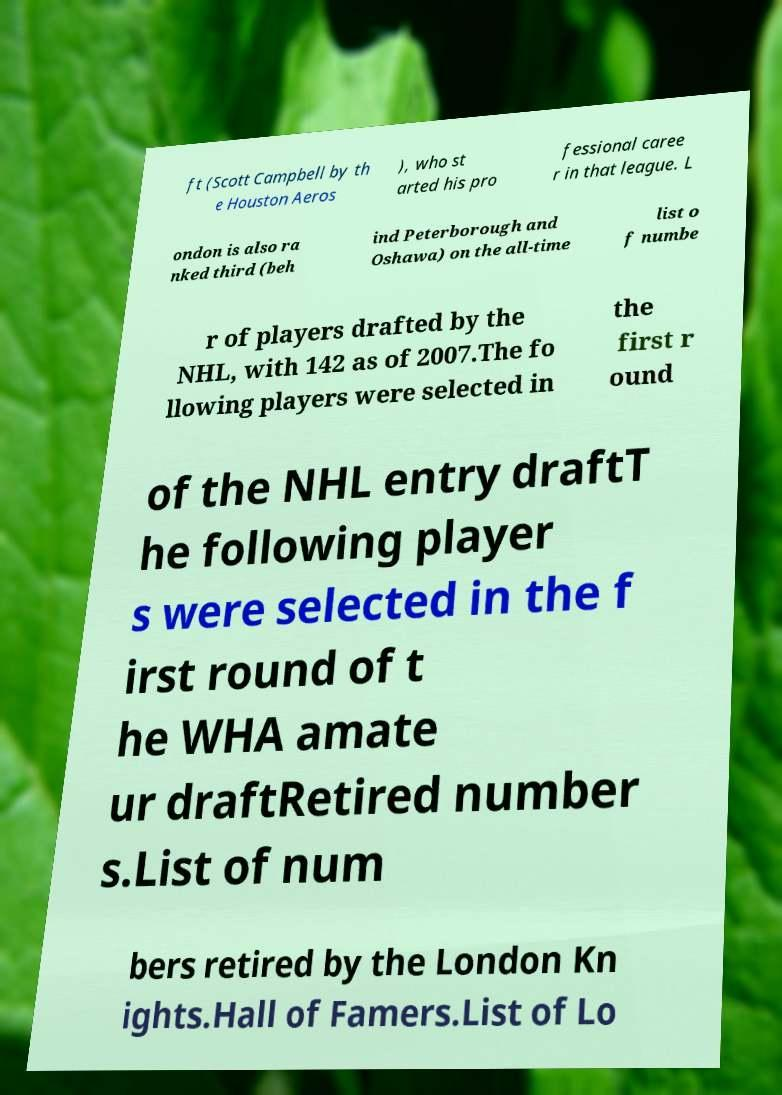Can you read and provide the text displayed in the image?This photo seems to have some interesting text. Can you extract and type it out for me? ft (Scott Campbell by th e Houston Aeros ), who st arted his pro fessional caree r in that league. L ondon is also ra nked third (beh ind Peterborough and Oshawa) on the all-time list o f numbe r of players drafted by the NHL, with 142 as of 2007.The fo llowing players were selected in the first r ound of the NHL entry draftT he following player s were selected in the f irst round of t he WHA amate ur draftRetired number s.List of num bers retired by the London Kn ights.Hall of Famers.List of Lo 